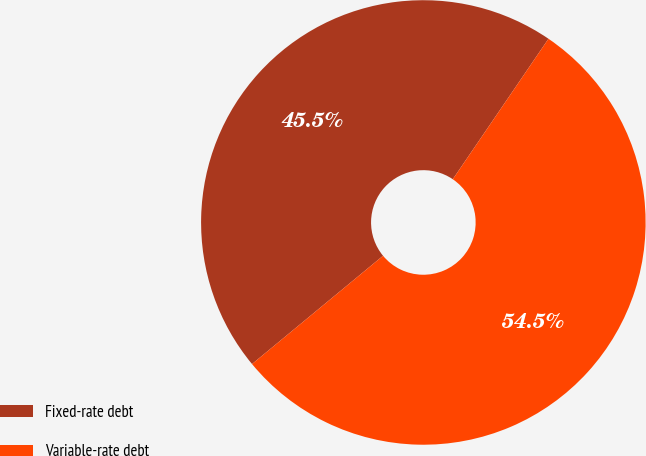Convert chart. <chart><loc_0><loc_0><loc_500><loc_500><pie_chart><fcel>Fixed-rate debt<fcel>Variable-rate debt<nl><fcel>45.51%<fcel>54.49%<nl></chart> 